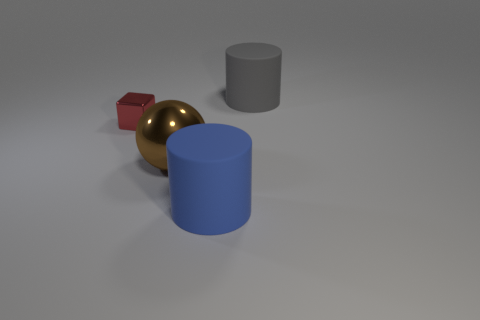Do the blue rubber cylinder and the gray matte thing have the same size?
Provide a succinct answer. Yes. How many matte things are right of the blue thing and to the left of the gray matte cylinder?
Your answer should be compact. 0. What number of blue objects are big objects or matte objects?
Your answer should be very brief. 1. What number of rubber things are either big red blocks or balls?
Keep it short and to the point. 0. Are there any brown shiny objects?
Provide a short and direct response. Yes. Is the small red metal object the same shape as the large gray thing?
Make the answer very short. No. There is a big rubber object that is right of the large matte object that is in front of the metal cube; what number of big rubber cylinders are in front of it?
Make the answer very short. 1. What is the material of the object that is behind the big brown metallic ball and left of the blue cylinder?
Your answer should be very brief. Metal. The big object that is both behind the large blue cylinder and left of the big gray cylinder is what color?
Offer a very short reply. Brown. Are there any other things that are the same color as the small shiny block?
Your answer should be compact. No. 